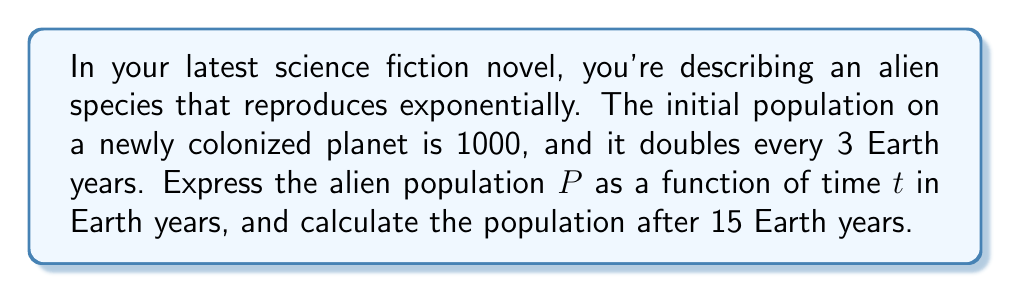Can you solve this math problem? To model this alien population growth, we'll use an exponential function. The general form of an exponential growth function is:

$$P(t) = P_0 \cdot b^{t/k}$$

Where:
$P(t)$ is the population at time $t$
$P_0$ is the initial population
$b$ is the growth factor
$k$ is the time it takes for one growth cycle

Given:
- Initial population $P_0 = 1000$
- The population doubles (growth factor $b = 2$) every 3 years ($k = 3$)

Plugging these values into our function:

$$P(t) = 1000 \cdot 2^{t/3}$$

To find the population after 15 years, we substitute $t = 15$:

$$P(15) = 1000 \cdot 2^{15/3}$$
$$P(15) = 1000 \cdot 2^5$$
$$P(15) = 1000 \cdot 32$$
$$P(15) = 32000$$

Therefore, after 15 Earth years, the alien population will be 32,000.
Answer: The alien population function is $P(t) = 1000 \cdot 2^{t/3}$, and the population after 15 Earth years will be 32,000. 